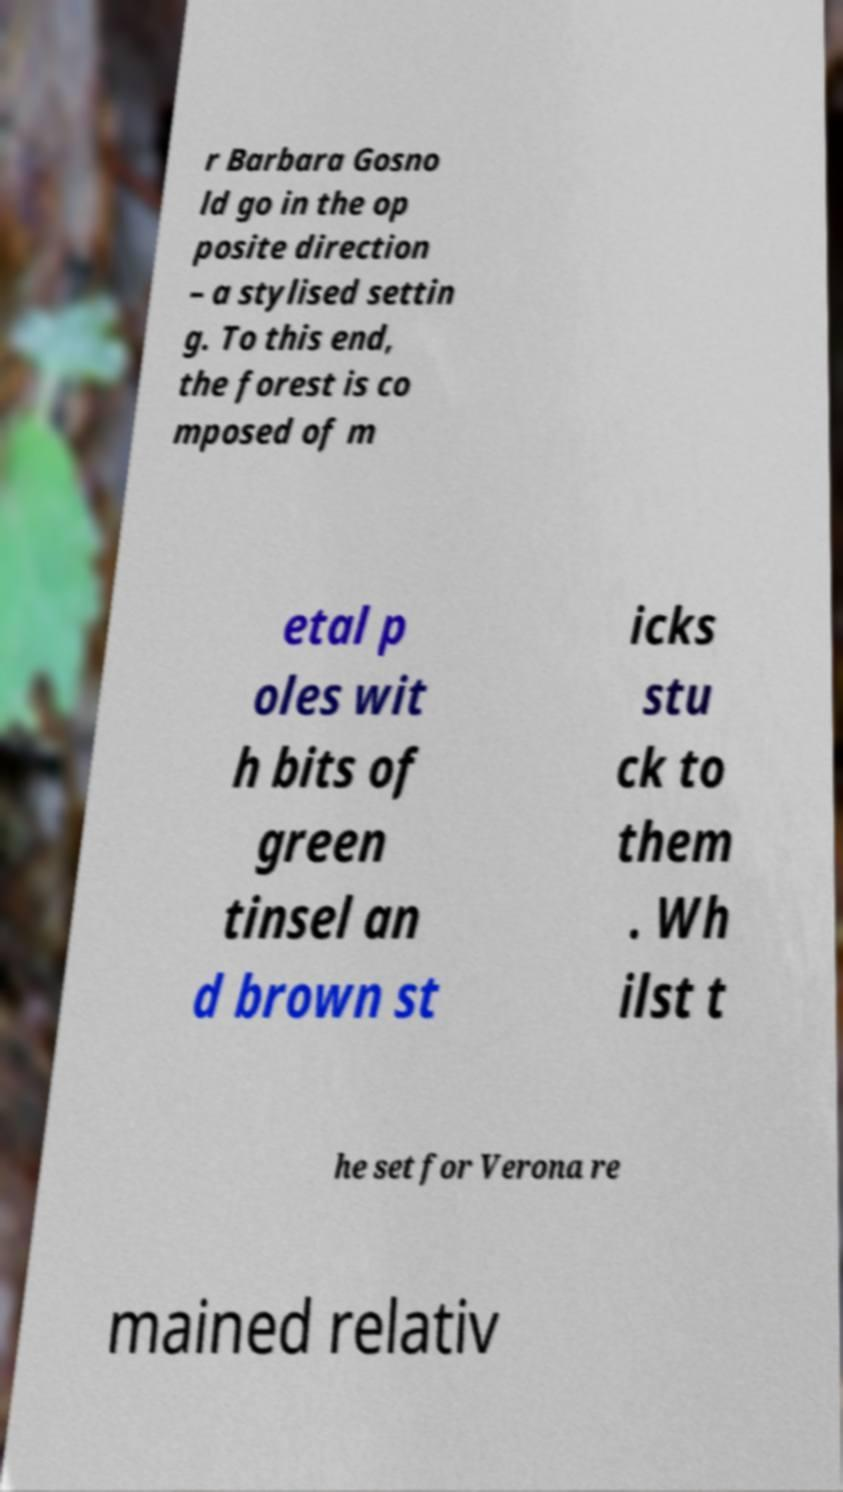Can you read and provide the text displayed in the image?This photo seems to have some interesting text. Can you extract and type it out for me? r Barbara Gosno ld go in the op posite direction – a stylised settin g. To this end, the forest is co mposed of m etal p oles wit h bits of green tinsel an d brown st icks stu ck to them . Wh ilst t he set for Verona re mained relativ 